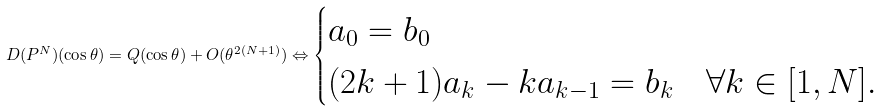Convert formula to latex. <formula><loc_0><loc_0><loc_500><loc_500>D ( P ^ { N } ) ( \cos \theta ) = Q ( \cos \theta ) + O ( \theta ^ { 2 ( N + 1 ) } ) \Leftrightarrow \begin{cases} a _ { 0 } = b _ { 0 } & \\ ( 2 k + 1 ) a _ { k } - k a _ { k - 1 } = b _ { k } & \forall k \in [ 1 , N ] . \end{cases}</formula> 